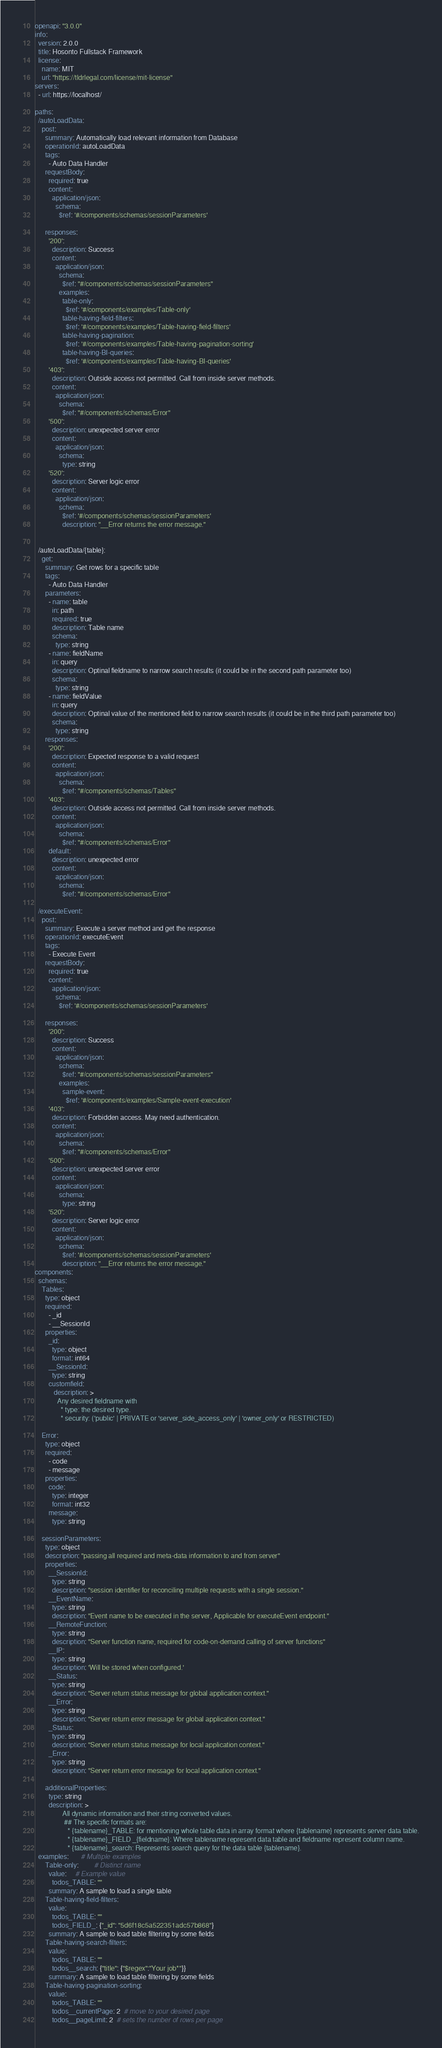Convert code to text. <code><loc_0><loc_0><loc_500><loc_500><_YAML_>openapi: "3.0.0"
info:
  version: 2.0.0
  title: Hosonto Fullstack Framework
  license:
    name: MIT
    url: "https://tldrlegal.com/license/mit-license"
servers:
  - url: https://localhost/
  
paths:
  /autoLoadData:
    post:
      summary: Automatically load relevant information from Database
      operationId: autoLoadData
      tags:
        - Auto Data Handler
      requestBody:
        required: true
        content:
          application/json:
            schema:
              $ref: '#/components/schemas/sessionParameters'
  
      responses:
        '200':
          description: Success
          content:
            application/json:
              schema:
                $ref: "#/components/schemas/sessionParameters"
              examples:
                table-only:
                  $ref: '#/components/examples/Table-only'
                table-having-field-filters:
                  $ref: '#/components/examples/Table-having-field-filters'
                table-having-pagination:
                  $ref: '#/components/examples/Table-having-pagination-sorting'
                table-having-BI-queries:
                  $ref: '#/components/examples/Table-having-BI-queries'
        '403':
          description: Outside access not permitted. Call from inside server methods.
          content:
            application/json:
              schema:
                $ref: "#/components/schemas/Error"
        '500':
          description: unexpected server error
          content:
            application/json:
              schema: 
                type: string
        '520':
          description: Server logic error
          content:
            application/json:
              schema:
                $ref: '#/components/schemas/sessionParameters'
                description: "__Error returns the error message."
  
      
  /autoLoadData/{table}:
    get:
      summary: Get rows for a specific table
      tags:
        - Auto Data Handler
      parameters:
        - name: table
          in: path
          required: true
          description: Table name 
          schema:
            type: string
        - name: fieldName
          in: query
          description: Optinal fieldname to narrow search results (it could be in the second path parameter too)
          schema:
            type: string
        - name: fieldValue
          in: query
          description: Optinal value of the mentioned field to narrow search results (it could be in the third path parameter too)
          schema:
            type: string    
      responses:
        '200':
          description: Expected response to a valid request
          content:
            application/json:
              schema:
                $ref: "#/components/schemas/Tables"
        '403':
          description: Outside access not permitted. Call from inside server methods.
          content:
            application/json:
              schema:
                $ref: "#/components/schemas/Error"
        default:
          description: unexpected error
          content:
            application/json:
              schema:
                $ref: "#/components/schemas/Error"

  /executeEvent:
    post:
      summary: Execute a server method and get the response
      operationId: executeEvent
      tags:
        - Execute Event
      requestBody:
        required: true
        content:
          application/json:
            schema:
              $ref: '#/components/schemas/sessionParameters'
  
      responses:
        '200':
          description: Success
          content:
            application/json:
              schema:
                $ref: "#/components/schemas/sessionParameters"
              examples:
                sample-event:
                  $ref: '#/components/examples/Sample-event-execution'
        '403':
          description: Forbidden access. May need authentication.
          content:
            application/json:
              schema:
                $ref: "#/components/schemas/Error"
        '500':
          description: unexpected server error
          content:
            application/json:
              schema: 
                type: string
        '520':
          description: Server logic error
          content:
            application/json:
              schema:
                $ref: '#/components/schemas/sessionParameters'
                description: "__Error returns the error message."
components:
  schemas:
    Tables:
      type: object
      required:
        - _id
        - __SessionId
      properties:
        _id:
          type: object
          format: int64
        __SessionId:
          type: string
        customfield:
           description: >
             Any desired fieldname with 
               * type: the desired type.
               * security: ('public' | PRIVATE or 'server_side_access_only' | 'owner_only' or RESTRICTED)
               
    Error:
      type: object
      required:
        - code
        - message
      properties:
        code:
          type: integer
          format: int32
        message:
          type: string
  
    sessionParameters:
      type: object
      description: "passing all required and meta-data information to and from server"
      properties:
        __SessionId:
          type: string
          description: "session identifier for reconciling multiple requests with a single session."
        __EventName: 
          type: string
          description: "Event name to be executed in the server, Applicable for executeEvent endpoint."
        __RemoteFunction: 
          type: string
          description: "Server function name, required for code-on-demand calling of server functions"
        __IP: 
          type: string
          description: 'Will be stored when configured.'
        __Status:
          type: string
          description: "Server return status message for global application context."
        __Error:
          type: string
          description: "Server return error message for global application context."
        _Status:
          type: string
          description: "Server return status message for local application context."
        _Error:
          type: string
          description: "Server return error message for local application context."
        
      additionalProperties:
        type: string
        description: >
                All dynamic information and their string converted values.
                 ## The specific formats are:
                   * {tablename}_TABLE: for mentioning whole table data in array format where {tablename} represents server data table.
                   * {tablename}_FIELD _{fieldname}: Where tablename represent data table and fieldname represent column name.
                   * {tablename}_search: Represents search query for the data table {tablename}.
  examples:       # Multiple examples
      Table-only:         # Distinct name
        value:     # Example value
          todos_TABLE: ""
        summary: A sample to load a single table 
      Table-having-field-filters: 
        value: 
          todos_TABLE: ""
          todos_FIELD_: {"_id": "5d6f18c5a522351adc57b868"}
        summary: A sample to load table filtering by some fields
      Table-having-search-filters: 
        value: 
          todos_TABLE: ""
          todos__search: {"title": {"$regex":"Your job*"}}
        summary: A sample to load table filtering by some fields
      Table-having-pagination-sorting: 
        value: 
          todos_TABLE: ""
          todos__currentPage: 2  # move to your desired page
          todos__pageLimit: 2  # sets the number of rows per page</code> 